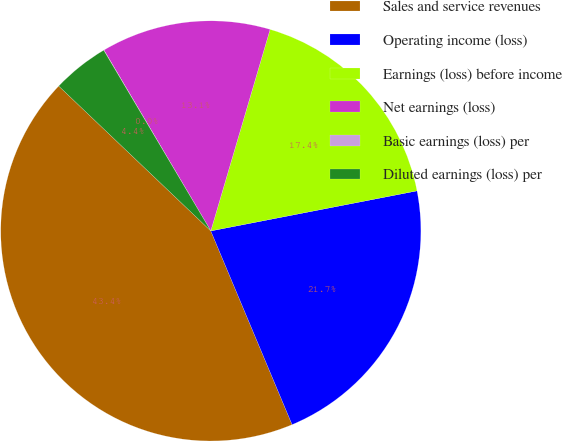Convert chart. <chart><loc_0><loc_0><loc_500><loc_500><pie_chart><fcel>Sales and service revenues<fcel>Operating income (loss)<fcel>Earnings (loss) before income<fcel>Net earnings (loss)<fcel>Basic earnings (loss) per<fcel>Diluted earnings (loss) per<nl><fcel>43.44%<fcel>21.73%<fcel>17.39%<fcel>13.05%<fcel>0.02%<fcel>4.37%<nl></chart> 